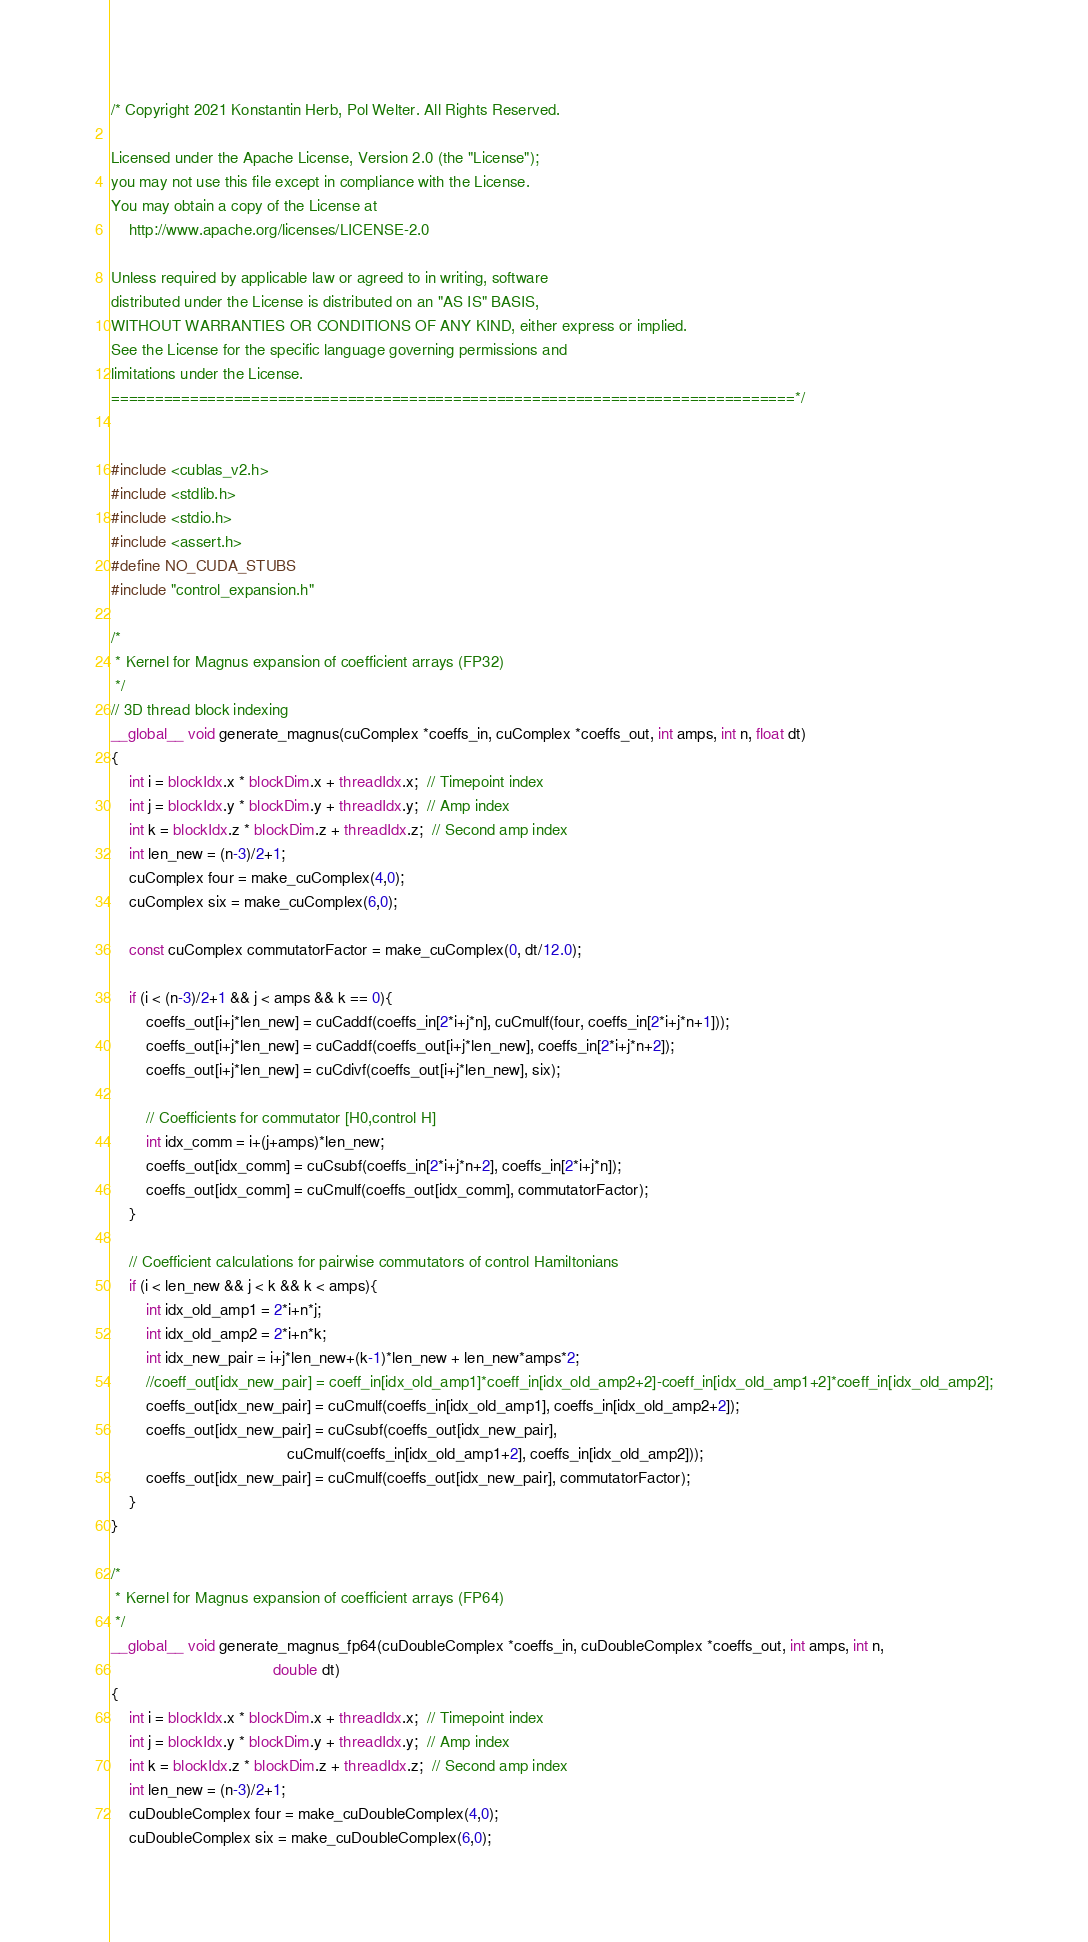<code> <loc_0><loc_0><loc_500><loc_500><_Cuda_>/* Copyright 2021 Konstantin Herb, Pol Welter. All Rights Reserved.

Licensed under the Apache License, Version 2.0 (the "License");
you may not use this file except in compliance with the License.
You may obtain a copy of the License at
    http://www.apache.org/licenses/LICENSE-2.0

Unless required by applicable law or agreed to in writing, software
distributed under the License is distributed on an "AS IS" BASIS,
WITHOUT WARRANTIES OR CONDITIONS OF ANY KIND, either express or implied.
See the License for the specific language governing permissions and
limitations under the License.
==============================================================================*/


#include <cublas_v2.h>
#include <stdlib.h>
#include <stdio.h>
#include <assert.h>
#define NO_CUDA_STUBS
#include "control_expansion.h"

/*
 * Kernel for Magnus expansion of coefficient arrays (FP32)
 */
// 3D thread block indexing
__global__ void generate_magnus(cuComplex *coeffs_in, cuComplex *coeffs_out, int amps, int n, float dt)
{
    int i = blockIdx.x * blockDim.x + threadIdx.x;  // Timepoint index
    int j = blockIdx.y * blockDim.y + threadIdx.y;  // Amp index
    int k = blockIdx.z * blockDim.z + threadIdx.z;  // Second amp index
    int len_new = (n-3)/2+1;
    cuComplex four = make_cuComplex(4,0);
    cuComplex six = make_cuComplex(6,0);

    const cuComplex commutatorFactor = make_cuComplex(0, dt/12.0);
    
    if (i < (n-3)/2+1 && j < amps && k == 0){
        coeffs_out[i+j*len_new] = cuCaddf(coeffs_in[2*i+j*n], cuCmulf(four, coeffs_in[2*i+j*n+1]));
        coeffs_out[i+j*len_new] = cuCaddf(coeffs_out[i+j*len_new], coeffs_in[2*i+j*n+2]);
        coeffs_out[i+j*len_new] = cuCdivf(coeffs_out[i+j*len_new], six);

        // Coefficients for commutator [H0,control H]
        int idx_comm = i+(j+amps)*len_new;
        coeffs_out[idx_comm] = cuCsubf(coeffs_in[2*i+j*n+2], coeffs_in[2*i+j*n]);
        coeffs_out[idx_comm] = cuCmulf(coeffs_out[idx_comm], commutatorFactor);
    }
    
    // Coefficient calculations for pairwise commutators of control Hamiltonians
    if (i < len_new && j < k && k < amps){
        int idx_old_amp1 = 2*i+n*j;
        int idx_old_amp2 = 2*i+n*k;
        int idx_new_pair = i+j*len_new+(k-1)*len_new + len_new*amps*2;
        //coeff_out[idx_new_pair] = coeff_in[idx_old_amp1]*coeff_in[idx_old_amp2+2]-coeff_in[idx_old_amp1+2]*coeff_in[idx_old_amp2];
        coeffs_out[idx_new_pair] = cuCmulf(coeffs_in[idx_old_amp1], coeffs_in[idx_old_amp2+2]);
        coeffs_out[idx_new_pair] = cuCsubf(coeffs_out[idx_new_pair],
                                        cuCmulf(coeffs_in[idx_old_amp1+2], coeffs_in[idx_old_amp2]));
        coeffs_out[idx_new_pair] = cuCmulf(coeffs_out[idx_new_pair], commutatorFactor);
    }
}

/*
 * Kernel for Magnus expansion of coefficient arrays (FP64)
 */
__global__ void generate_magnus_fp64(cuDoubleComplex *coeffs_in, cuDoubleComplex *coeffs_out, int amps, int n,
                                     double dt)
{
    int i = blockIdx.x * blockDim.x + threadIdx.x;  // Timepoint index
    int j = blockIdx.y * blockDim.y + threadIdx.y;  // Amp index
    int k = blockIdx.z * blockDim.z + threadIdx.z;  // Second amp index
    int len_new = (n-3)/2+1;
    cuDoubleComplex four = make_cuDoubleComplex(4,0);
    cuDoubleComplex six = make_cuDoubleComplex(6,0);
</code> 